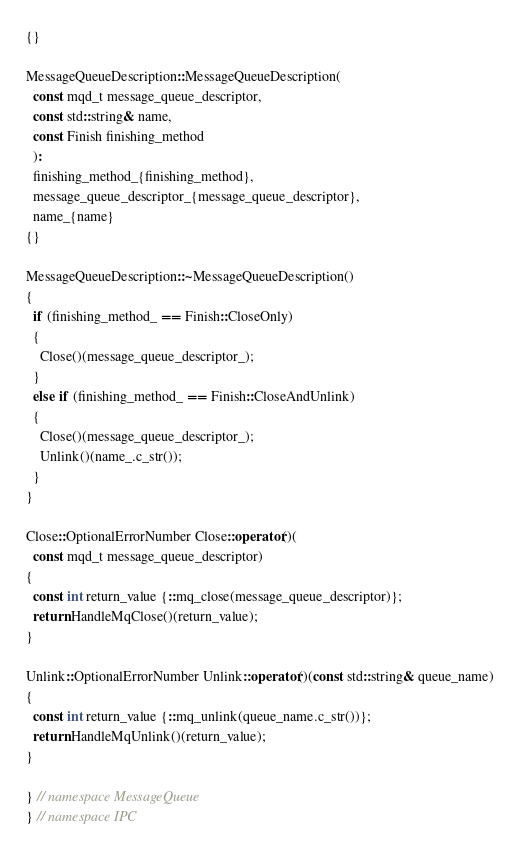<code> <loc_0><loc_0><loc_500><loc_500><_C++_>{}

MessageQueueDescription::MessageQueueDescription(
  const mqd_t message_queue_descriptor,
  const std::string& name,
  const Finish finishing_method
  ):
  finishing_method_{finishing_method},
  message_queue_descriptor_{message_queue_descriptor},
  name_{name}
{}

MessageQueueDescription::~MessageQueueDescription()
{
  if (finishing_method_ == Finish::CloseOnly)
  {
    Close()(message_queue_descriptor_);
  }
  else if (finishing_method_ == Finish::CloseAndUnlink)
  {
    Close()(message_queue_descriptor_);
    Unlink()(name_.c_str());
  }
}

Close::OptionalErrorNumber Close::operator()(
  const mqd_t message_queue_descriptor)
{
  const int return_value {::mq_close(message_queue_descriptor)};
  return HandleMqClose()(return_value);
}

Unlink::OptionalErrorNumber Unlink::operator()(const std::string& queue_name)
{
  const int return_value {::mq_unlink(queue_name.c_str())};
  return HandleMqUnlink()(return_value);
}

} // namespace MessageQueue
} // namespace IPC</code> 